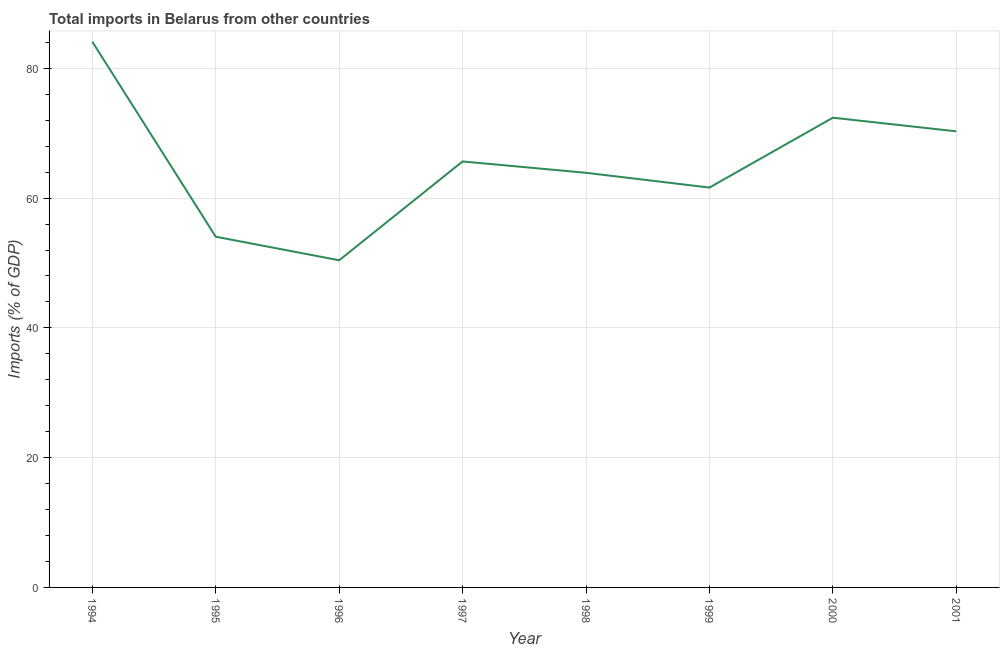What is the total imports in 1999?
Make the answer very short. 61.63. Across all years, what is the maximum total imports?
Provide a short and direct response. 84.1. Across all years, what is the minimum total imports?
Your response must be concise. 50.42. In which year was the total imports minimum?
Make the answer very short. 1996. What is the sum of the total imports?
Your answer should be compact. 522.47. What is the difference between the total imports in 1997 and 1998?
Your answer should be very brief. 1.75. What is the average total imports per year?
Give a very brief answer. 65.31. What is the median total imports?
Your answer should be compact. 64.78. Do a majority of the years between 1998 and 1994 (inclusive) have total imports greater than 60 %?
Offer a very short reply. Yes. What is the ratio of the total imports in 1995 to that in 2001?
Provide a short and direct response. 0.77. What is the difference between the highest and the second highest total imports?
Ensure brevity in your answer.  11.71. Is the sum of the total imports in 1994 and 1995 greater than the maximum total imports across all years?
Make the answer very short. Yes. What is the difference between the highest and the lowest total imports?
Your answer should be very brief. 33.68. Does the total imports monotonically increase over the years?
Offer a very short reply. No. Are the values on the major ticks of Y-axis written in scientific E-notation?
Make the answer very short. No. Does the graph contain any zero values?
Ensure brevity in your answer.  No. What is the title of the graph?
Your answer should be compact. Total imports in Belarus from other countries. What is the label or title of the X-axis?
Ensure brevity in your answer.  Year. What is the label or title of the Y-axis?
Your answer should be very brief. Imports (% of GDP). What is the Imports (% of GDP) of 1994?
Provide a succinct answer. 84.1. What is the Imports (% of GDP) in 1995?
Provide a succinct answer. 54.05. What is the Imports (% of GDP) in 1996?
Offer a terse response. 50.42. What is the Imports (% of GDP) of 1997?
Provide a short and direct response. 65.66. What is the Imports (% of GDP) in 1998?
Make the answer very short. 63.91. What is the Imports (% of GDP) in 1999?
Your answer should be very brief. 61.63. What is the Imports (% of GDP) in 2000?
Ensure brevity in your answer.  72.4. What is the Imports (% of GDP) in 2001?
Your answer should be very brief. 70.3. What is the difference between the Imports (% of GDP) in 1994 and 1995?
Ensure brevity in your answer.  30.05. What is the difference between the Imports (% of GDP) in 1994 and 1996?
Provide a short and direct response. 33.68. What is the difference between the Imports (% of GDP) in 1994 and 1997?
Ensure brevity in your answer.  18.45. What is the difference between the Imports (% of GDP) in 1994 and 1998?
Ensure brevity in your answer.  20.2. What is the difference between the Imports (% of GDP) in 1994 and 1999?
Keep it short and to the point. 22.47. What is the difference between the Imports (% of GDP) in 1994 and 2000?
Your response must be concise. 11.71. What is the difference between the Imports (% of GDP) in 1994 and 2001?
Ensure brevity in your answer.  13.81. What is the difference between the Imports (% of GDP) in 1995 and 1996?
Your answer should be very brief. 3.63. What is the difference between the Imports (% of GDP) in 1995 and 1997?
Provide a succinct answer. -11.6. What is the difference between the Imports (% of GDP) in 1995 and 1998?
Make the answer very short. -9.85. What is the difference between the Imports (% of GDP) in 1995 and 1999?
Your answer should be compact. -7.58. What is the difference between the Imports (% of GDP) in 1995 and 2000?
Provide a succinct answer. -18.34. What is the difference between the Imports (% of GDP) in 1995 and 2001?
Keep it short and to the point. -16.24. What is the difference between the Imports (% of GDP) in 1996 and 1997?
Your answer should be very brief. -15.23. What is the difference between the Imports (% of GDP) in 1996 and 1998?
Ensure brevity in your answer.  -13.48. What is the difference between the Imports (% of GDP) in 1996 and 1999?
Provide a short and direct response. -11.21. What is the difference between the Imports (% of GDP) in 1996 and 2000?
Your answer should be compact. -21.97. What is the difference between the Imports (% of GDP) in 1996 and 2001?
Your answer should be compact. -19.87. What is the difference between the Imports (% of GDP) in 1997 and 1998?
Provide a succinct answer. 1.75. What is the difference between the Imports (% of GDP) in 1997 and 1999?
Provide a short and direct response. 4.02. What is the difference between the Imports (% of GDP) in 1997 and 2000?
Provide a short and direct response. -6.74. What is the difference between the Imports (% of GDP) in 1997 and 2001?
Give a very brief answer. -4.64. What is the difference between the Imports (% of GDP) in 1998 and 1999?
Your answer should be compact. 2.27. What is the difference between the Imports (% of GDP) in 1998 and 2000?
Keep it short and to the point. -8.49. What is the difference between the Imports (% of GDP) in 1998 and 2001?
Your response must be concise. -6.39. What is the difference between the Imports (% of GDP) in 1999 and 2000?
Offer a terse response. -10.77. What is the difference between the Imports (% of GDP) in 1999 and 2001?
Provide a short and direct response. -8.67. What is the difference between the Imports (% of GDP) in 2000 and 2001?
Offer a terse response. 2.1. What is the ratio of the Imports (% of GDP) in 1994 to that in 1995?
Your answer should be very brief. 1.56. What is the ratio of the Imports (% of GDP) in 1994 to that in 1996?
Your answer should be compact. 1.67. What is the ratio of the Imports (% of GDP) in 1994 to that in 1997?
Provide a short and direct response. 1.28. What is the ratio of the Imports (% of GDP) in 1994 to that in 1998?
Ensure brevity in your answer.  1.32. What is the ratio of the Imports (% of GDP) in 1994 to that in 1999?
Your answer should be very brief. 1.36. What is the ratio of the Imports (% of GDP) in 1994 to that in 2000?
Provide a succinct answer. 1.16. What is the ratio of the Imports (% of GDP) in 1994 to that in 2001?
Offer a terse response. 1.2. What is the ratio of the Imports (% of GDP) in 1995 to that in 1996?
Offer a very short reply. 1.07. What is the ratio of the Imports (% of GDP) in 1995 to that in 1997?
Provide a succinct answer. 0.82. What is the ratio of the Imports (% of GDP) in 1995 to that in 1998?
Offer a terse response. 0.85. What is the ratio of the Imports (% of GDP) in 1995 to that in 1999?
Provide a short and direct response. 0.88. What is the ratio of the Imports (% of GDP) in 1995 to that in 2000?
Your response must be concise. 0.75. What is the ratio of the Imports (% of GDP) in 1995 to that in 2001?
Give a very brief answer. 0.77. What is the ratio of the Imports (% of GDP) in 1996 to that in 1997?
Provide a short and direct response. 0.77. What is the ratio of the Imports (% of GDP) in 1996 to that in 1998?
Provide a short and direct response. 0.79. What is the ratio of the Imports (% of GDP) in 1996 to that in 1999?
Provide a short and direct response. 0.82. What is the ratio of the Imports (% of GDP) in 1996 to that in 2000?
Your answer should be very brief. 0.7. What is the ratio of the Imports (% of GDP) in 1996 to that in 2001?
Provide a short and direct response. 0.72. What is the ratio of the Imports (% of GDP) in 1997 to that in 1999?
Your answer should be very brief. 1.06. What is the ratio of the Imports (% of GDP) in 1997 to that in 2000?
Make the answer very short. 0.91. What is the ratio of the Imports (% of GDP) in 1997 to that in 2001?
Provide a short and direct response. 0.93. What is the ratio of the Imports (% of GDP) in 1998 to that in 2000?
Offer a terse response. 0.88. What is the ratio of the Imports (% of GDP) in 1998 to that in 2001?
Offer a very short reply. 0.91. What is the ratio of the Imports (% of GDP) in 1999 to that in 2000?
Provide a succinct answer. 0.85. What is the ratio of the Imports (% of GDP) in 1999 to that in 2001?
Your response must be concise. 0.88. What is the ratio of the Imports (% of GDP) in 2000 to that in 2001?
Offer a terse response. 1.03. 